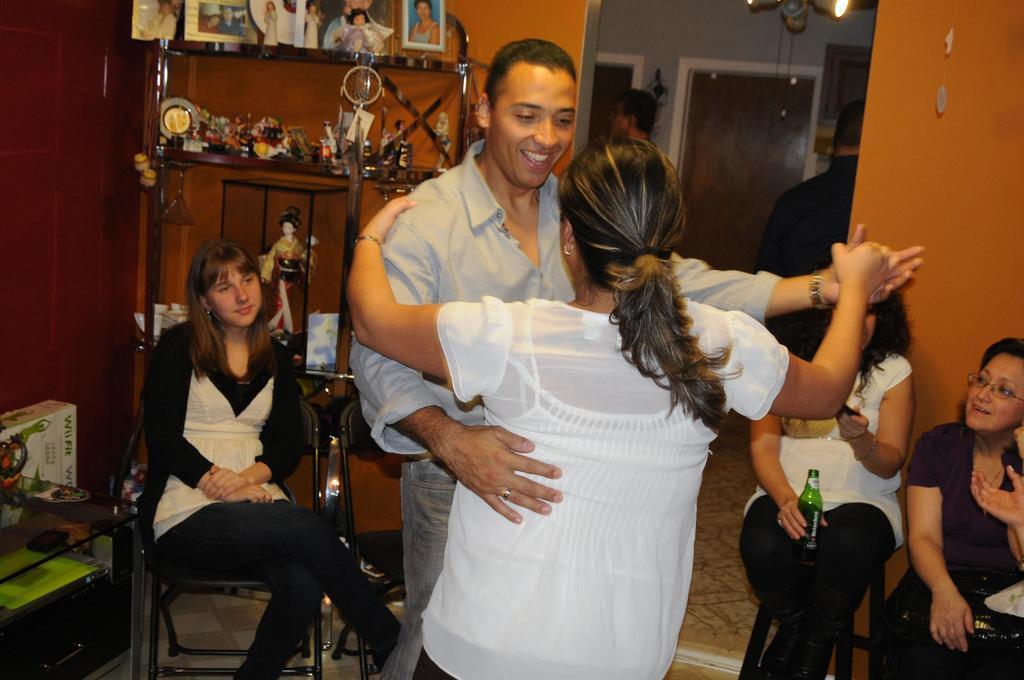What are the two people in the image doing? There is a woman and a man dancing in the image. How many other women are in the image, and what are they doing? There are three other women sitting on chairs in the image. What can be seen in the background of the image? There is a wall visible in the image. What type of objects can be seen in the image? There are toys and a frame on a rack in the image. What architectural feature is present in the image? There is a door in the image. How many kittens are sitting on the desk in the image? There is no desk or kittens present in the image. What emotion do the people in the image express towards each other? The image does not convey any specific emotions, so it cannot be determined how the people feel about each other. 